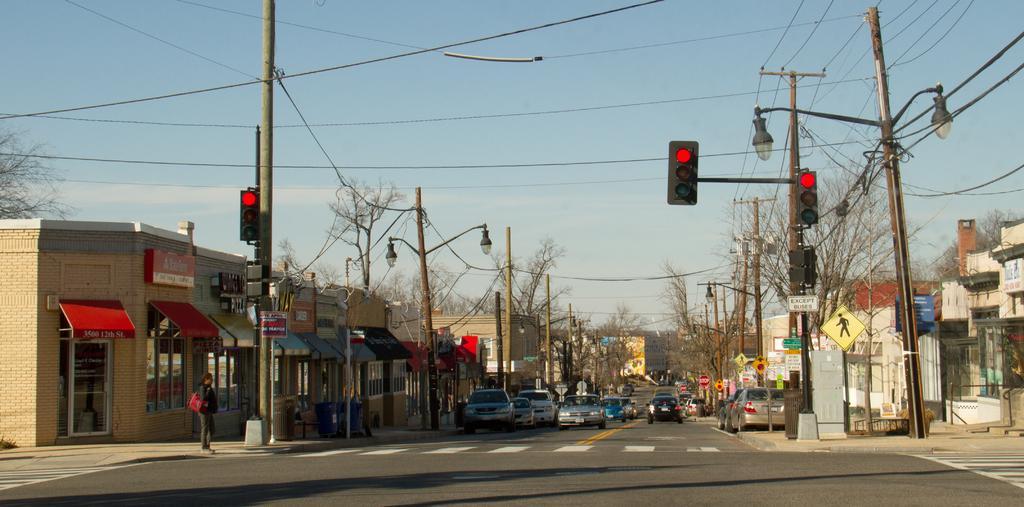Can you describe this image briefly? In this image we can see a few vehicles on a road. On the left side, we can see buildings, trees, poles, person and at traffic lights. On the right side, we can see buildings, trees, poles, boards and traffic lights. At the top we can see the sky and wires. 